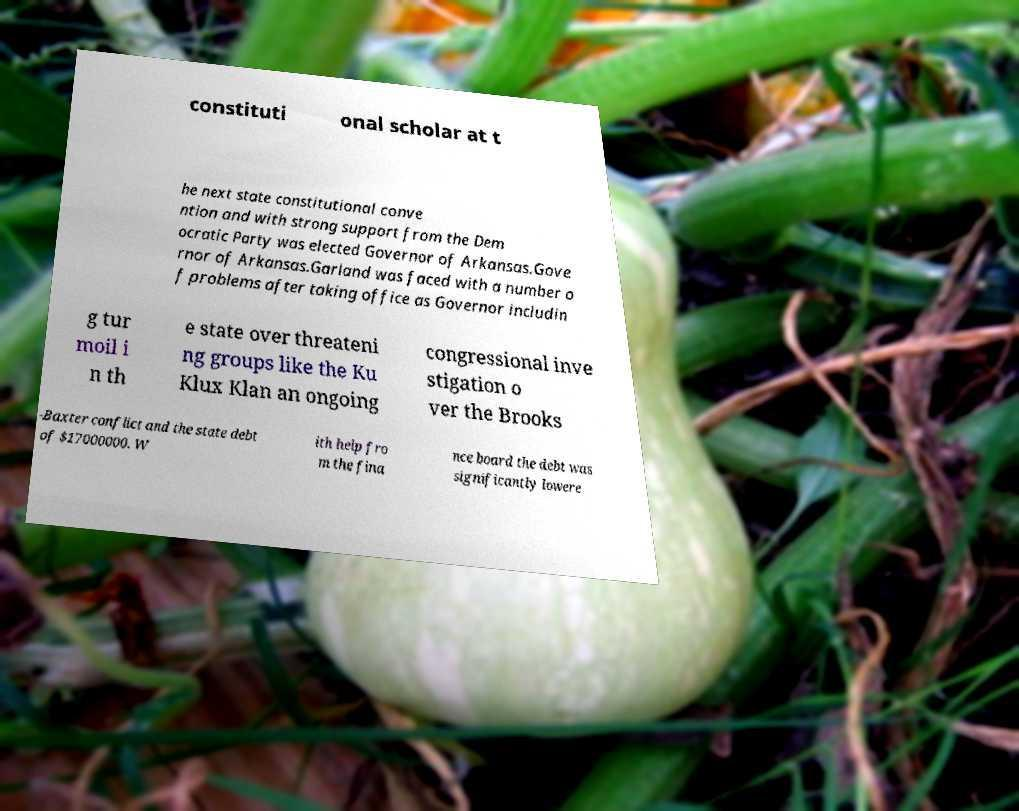There's text embedded in this image that I need extracted. Can you transcribe it verbatim? constituti onal scholar at t he next state constitutional conve ntion and with strong support from the Dem ocratic Party was elected Governor of Arkansas.Gove rnor of Arkansas.Garland was faced with a number o f problems after taking office as Governor includin g tur moil i n th e state over threateni ng groups like the Ku Klux Klan an ongoing congressional inve stigation o ver the Brooks -Baxter conflict and the state debt of $17000000. W ith help fro m the fina nce board the debt was significantly lowere 